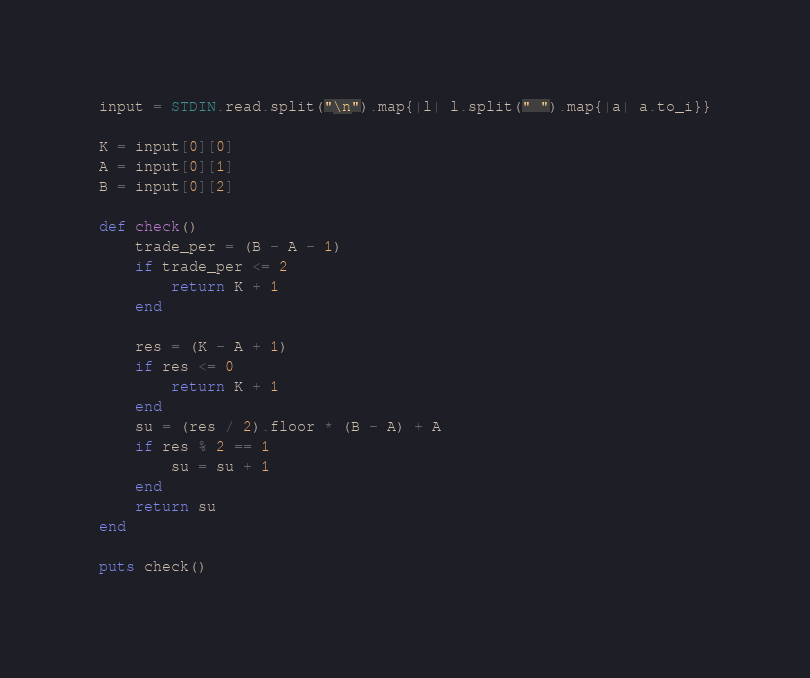Convert code to text. <code><loc_0><loc_0><loc_500><loc_500><_Ruby_>input = STDIN.read.split("\n").map{|l| l.split(" ").map{|a| a.to_i}}

K = input[0][0]
A = input[0][1]
B = input[0][2]

def check()
    trade_per = (B - A - 1)
    if trade_per <= 2 
        return K + 1
    end

    res = (K - A + 1) 
    if res <= 0
        return K + 1
    end
    su = (res / 2).floor * (B - A) + A
    if res % 2 == 1
        su = su + 1
    end
    return su
end

puts check()</code> 